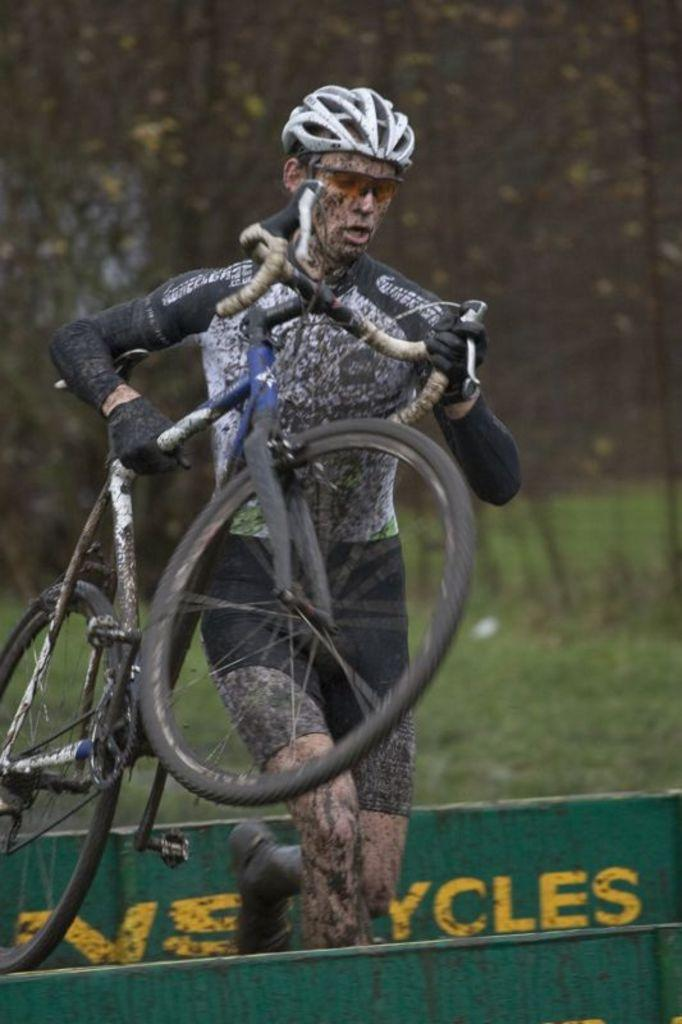What is the person in the image holding? The person is holding a bicycle in the image. What else can be seen in the image besides the person and the bicycle? There is an object with text in the image. Can you describe the background of the image? The background of the image is blurred. What type of copper development can be seen in the image? There is no copper development present in the image. What type of mountain is visible in the background of the image? There is no mountain visible in the image; the background is blurred. 